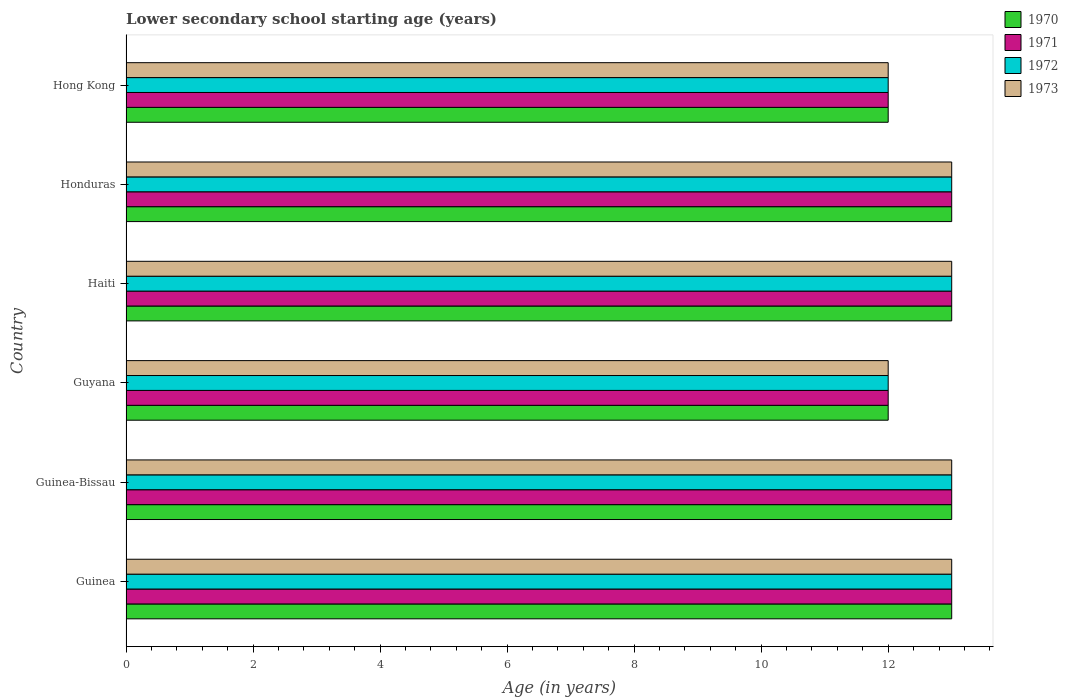How many different coloured bars are there?
Provide a short and direct response. 4. How many groups of bars are there?
Your response must be concise. 6. Are the number of bars per tick equal to the number of legend labels?
Keep it short and to the point. Yes. Are the number of bars on each tick of the Y-axis equal?
Give a very brief answer. Yes. How many bars are there on the 6th tick from the bottom?
Make the answer very short. 4. What is the label of the 2nd group of bars from the top?
Make the answer very short. Honduras. What is the lower secondary school starting age of children in 1970 in Guyana?
Offer a terse response. 12. Across all countries, what is the maximum lower secondary school starting age of children in 1973?
Give a very brief answer. 13. In which country was the lower secondary school starting age of children in 1972 maximum?
Offer a very short reply. Guinea. In which country was the lower secondary school starting age of children in 1970 minimum?
Make the answer very short. Guyana. What is the total lower secondary school starting age of children in 1970 in the graph?
Ensure brevity in your answer.  76. What is the average lower secondary school starting age of children in 1973 per country?
Offer a terse response. 12.67. What is the ratio of the lower secondary school starting age of children in 1973 in Guyana to that in Haiti?
Your answer should be compact. 0.92. Is the lower secondary school starting age of children in 1972 in Guyana less than that in Haiti?
Your response must be concise. Yes. What is the difference between the highest and the second highest lower secondary school starting age of children in 1972?
Give a very brief answer. 0. What is the difference between the highest and the lowest lower secondary school starting age of children in 1973?
Make the answer very short. 1. In how many countries, is the lower secondary school starting age of children in 1971 greater than the average lower secondary school starting age of children in 1971 taken over all countries?
Provide a succinct answer. 4. Is the sum of the lower secondary school starting age of children in 1973 in Guinea-Bissau and Guyana greater than the maximum lower secondary school starting age of children in 1970 across all countries?
Keep it short and to the point. Yes. Is it the case that in every country, the sum of the lower secondary school starting age of children in 1973 and lower secondary school starting age of children in 1970 is greater than the sum of lower secondary school starting age of children in 1971 and lower secondary school starting age of children in 1972?
Keep it short and to the point. No. What does the 2nd bar from the bottom in Guinea-Bissau represents?
Provide a short and direct response. 1971. Is it the case that in every country, the sum of the lower secondary school starting age of children in 1971 and lower secondary school starting age of children in 1970 is greater than the lower secondary school starting age of children in 1972?
Provide a succinct answer. Yes. How many bars are there?
Offer a very short reply. 24. Are all the bars in the graph horizontal?
Ensure brevity in your answer.  Yes. What is the difference between two consecutive major ticks on the X-axis?
Keep it short and to the point. 2. Does the graph contain any zero values?
Ensure brevity in your answer.  No. Where does the legend appear in the graph?
Your answer should be very brief. Top right. What is the title of the graph?
Provide a succinct answer. Lower secondary school starting age (years). What is the label or title of the X-axis?
Provide a short and direct response. Age (in years). What is the Age (in years) in 1970 in Guinea?
Make the answer very short. 13. What is the Age (in years) in 1972 in Guinea?
Ensure brevity in your answer.  13. What is the Age (in years) in 1973 in Guinea?
Ensure brevity in your answer.  13. What is the Age (in years) in 1970 in Guinea-Bissau?
Provide a succinct answer. 13. What is the Age (in years) of 1972 in Guinea-Bissau?
Keep it short and to the point. 13. What is the Age (in years) of 1973 in Guinea-Bissau?
Offer a terse response. 13. What is the Age (in years) of 1970 in Guyana?
Offer a very short reply. 12. What is the Age (in years) in 1971 in Guyana?
Provide a short and direct response. 12. What is the Age (in years) of 1972 in Guyana?
Offer a terse response. 12. What is the Age (in years) in 1973 in Haiti?
Keep it short and to the point. 13. What is the Age (in years) in 1970 in Honduras?
Give a very brief answer. 13. What is the Age (in years) in 1970 in Hong Kong?
Make the answer very short. 12. What is the Age (in years) of 1971 in Hong Kong?
Offer a terse response. 12. What is the Age (in years) of 1973 in Hong Kong?
Your response must be concise. 12. Across all countries, what is the maximum Age (in years) in 1970?
Provide a succinct answer. 13. Across all countries, what is the maximum Age (in years) in 1972?
Give a very brief answer. 13. Across all countries, what is the minimum Age (in years) of 1971?
Your answer should be compact. 12. Across all countries, what is the minimum Age (in years) of 1973?
Provide a short and direct response. 12. What is the total Age (in years) in 1970 in the graph?
Ensure brevity in your answer.  76. What is the total Age (in years) of 1971 in the graph?
Keep it short and to the point. 76. What is the difference between the Age (in years) of 1970 in Guinea and that in Guinea-Bissau?
Give a very brief answer. 0. What is the difference between the Age (in years) in 1973 in Guinea and that in Guinea-Bissau?
Provide a succinct answer. 0. What is the difference between the Age (in years) of 1973 in Guinea and that in Guyana?
Keep it short and to the point. 1. What is the difference between the Age (in years) of 1972 in Guinea and that in Haiti?
Ensure brevity in your answer.  0. What is the difference between the Age (in years) of 1970 in Guinea and that in Honduras?
Offer a very short reply. 0. What is the difference between the Age (in years) of 1972 in Guinea and that in Honduras?
Your answer should be very brief. 0. What is the difference between the Age (in years) in 1973 in Guinea and that in Honduras?
Your response must be concise. 0. What is the difference between the Age (in years) of 1970 in Guinea and that in Hong Kong?
Keep it short and to the point. 1. What is the difference between the Age (in years) of 1972 in Guinea and that in Hong Kong?
Offer a very short reply. 1. What is the difference between the Age (in years) of 1973 in Guinea and that in Hong Kong?
Give a very brief answer. 1. What is the difference between the Age (in years) in 1971 in Guinea-Bissau and that in Haiti?
Offer a very short reply. 0. What is the difference between the Age (in years) of 1972 in Guinea-Bissau and that in Haiti?
Give a very brief answer. 0. What is the difference between the Age (in years) of 1973 in Guinea-Bissau and that in Haiti?
Ensure brevity in your answer.  0. What is the difference between the Age (in years) of 1971 in Guinea-Bissau and that in Honduras?
Keep it short and to the point. 0. What is the difference between the Age (in years) in 1970 in Guinea-Bissau and that in Hong Kong?
Offer a very short reply. 1. What is the difference between the Age (in years) of 1973 in Guinea-Bissau and that in Hong Kong?
Ensure brevity in your answer.  1. What is the difference between the Age (in years) in 1970 in Guyana and that in Haiti?
Provide a succinct answer. -1. What is the difference between the Age (in years) in 1971 in Guyana and that in Honduras?
Your response must be concise. -1. What is the difference between the Age (in years) of 1973 in Guyana and that in Honduras?
Your answer should be very brief. -1. What is the difference between the Age (in years) in 1971 in Guyana and that in Hong Kong?
Keep it short and to the point. 0. What is the difference between the Age (in years) of 1970 in Haiti and that in Honduras?
Ensure brevity in your answer.  0. What is the difference between the Age (in years) of 1972 in Haiti and that in Honduras?
Offer a very short reply. 0. What is the difference between the Age (in years) in 1972 in Haiti and that in Hong Kong?
Provide a short and direct response. 1. What is the difference between the Age (in years) of 1973 in Haiti and that in Hong Kong?
Offer a terse response. 1. What is the difference between the Age (in years) of 1971 in Honduras and that in Hong Kong?
Provide a succinct answer. 1. What is the difference between the Age (in years) of 1970 in Guinea and the Age (in years) of 1971 in Guinea-Bissau?
Your answer should be compact. 0. What is the difference between the Age (in years) in 1970 in Guinea and the Age (in years) in 1972 in Guinea-Bissau?
Your answer should be compact. 0. What is the difference between the Age (in years) in 1971 in Guinea and the Age (in years) in 1973 in Guinea-Bissau?
Keep it short and to the point. 0. What is the difference between the Age (in years) in 1972 in Guinea and the Age (in years) in 1973 in Guinea-Bissau?
Provide a succinct answer. 0. What is the difference between the Age (in years) in 1970 in Guinea and the Age (in years) in 1972 in Guyana?
Provide a succinct answer. 1. What is the difference between the Age (in years) of 1971 in Guinea and the Age (in years) of 1973 in Guyana?
Your response must be concise. 1. What is the difference between the Age (in years) in 1972 in Guinea and the Age (in years) in 1973 in Guyana?
Your answer should be very brief. 1. What is the difference between the Age (in years) in 1970 in Guinea and the Age (in years) in 1973 in Haiti?
Give a very brief answer. 0. What is the difference between the Age (in years) of 1971 in Guinea and the Age (in years) of 1973 in Haiti?
Give a very brief answer. 0. What is the difference between the Age (in years) of 1970 in Guinea and the Age (in years) of 1972 in Honduras?
Keep it short and to the point. 0. What is the difference between the Age (in years) in 1971 in Guinea and the Age (in years) in 1973 in Honduras?
Your answer should be compact. 0. What is the difference between the Age (in years) in 1970 in Guinea and the Age (in years) in 1971 in Hong Kong?
Your response must be concise. 1. What is the difference between the Age (in years) of 1970 in Guinea and the Age (in years) of 1972 in Hong Kong?
Your answer should be compact. 1. What is the difference between the Age (in years) in 1971 in Guinea and the Age (in years) in 1972 in Hong Kong?
Offer a terse response. 1. What is the difference between the Age (in years) of 1971 in Guinea and the Age (in years) of 1973 in Hong Kong?
Your response must be concise. 1. What is the difference between the Age (in years) of 1972 in Guinea and the Age (in years) of 1973 in Hong Kong?
Keep it short and to the point. 1. What is the difference between the Age (in years) in 1970 in Guinea-Bissau and the Age (in years) in 1971 in Guyana?
Give a very brief answer. 1. What is the difference between the Age (in years) in 1970 in Guinea-Bissau and the Age (in years) in 1973 in Guyana?
Provide a succinct answer. 1. What is the difference between the Age (in years) in 1971 in Guinea-Bissau and the Age (in years) in 1973 in Guyana?
Keep it short and to the point. 1. What is the difference between the Age (in years) of 1972 in Guinea-Bissau and the Age (in years) of 1973 in Guyana?
Offer a terse response. 1. What is the difference between the Age (in years) of 1970 in Guinea-Bissau and the Age (in years) of 1972 in Haiti?
Your response must be concise. 0. What is the difference between the Age (in years) of 1970 in Guinea-Bissau and the Age (in years) of 1973 in Haiti?
Keep it short and to the point. 0. What is the difference between the Age (in years) of 1972 in Guinea-Bissau and the Age (in years) of 1973 in Haiti?
Provide a succinct answer. 0. What is the difference between the Age (in years) of 1970 in Guinea-Bissau and the Age (in years) of 1971 in Honduras?
Offer a terse response. 0. What is the difference between the Age (in years) of 1970 in Guinea-Bissau and the Age (in years) of 1972 in Honduras?
Keep it short and to the point. 0. What is the difference between the Age (in years) of 1970 in Guinea-Bissau and the Age (in years) of 1973 in Honduras?
Offer a very short reply. 0. What is the difference between the Age (in years) in 1971 in Guinea-Bissau and the Age (in years) in 1972 in Honduras?
Your answer should be compact. 0. What is the difference between the Age (in years) in 1971 in Guinea-Bissau and the Age (in years) in 1973 in Honduras?
Provide a short and direct response. 0. What is the difference between the Age (in years) of 1970 in Guinea-Bissau and the Age (in years) of 1971 in Hong Kong?
Your answer should be very brief. 1. What is the difference between the Age (in years) in 1970 in Guinea-Bissau and the Age (in years) in 1972 in Hong Kong?
Give a very brief answer. 1. What is the difference between the Age (in years) in 1971 in Guinea-Bissau and the Age (in years) in 1972 in Hong Kong?
Provide a short and direct response. 1. What is the difference between the Age (in years) in 1972 in Guinea-Bissau and the Age (in years) in 1973 in Hong Kong?
Ensure brevity in your answer.  1. What is the difference between the Age (in years) of 1970 in Guyana and the Age (in years) of 1971 in Haiti?
Your response must be concise. -1. What is the difference between the Age (in years) of 1971 in Guyana and the Age (in years) of 1972 in Haiti?
Ensure brevity in your answer.  -1. What is the difference between the Age (in years) of 1971 in Guyana and the Age (in years) of 1973 in Haiti?
Your response must be concise. -1. What is the difference between the Age (in years) of 1972 in Guyana and the Age (in years) of 1973 in Haiti?
Keep it short and to the point. -1. What is the difference between the Age (in years) in 1970 in Guyana and the Age (in years) in 1971 in Honduras?
Keep it short and to the point. -1. What is the difference between the Age (in years) in 1970 in Guyana and the Age (in years) in 1973 in Honduras?
Your response must be concise. -1. What is the difference between the Age (in years) in 1972 in Guyana and the Age (in years) in 1973 in Honduras?
Your answer should be very brief. -1. What is the difference between the Age (in years) of 1970 in Guyana and the Age (in years) of 1971 in Hong Kong?
Offer a terse response. 0. What is the difference between the Age (in years) of 1971 in Guyana and the Age (in years) of 1972 in Hong Kong?
Give a very brief answer. 0. What is the difference between the Age (in years) in 1972 in Guyana and the Age (in years) in 1973 in Hong Kong?
Give a very brief answer. 0. What is the difference between the Age (in years) of 1970 in Haiti and the Age (in years) of 1972 in Honduras?
Make the answer very short. 0. What is the difference between the Age (in years) in 1970 in Haiti and the Age (in years) in 1973 in Honduras?
Give a very brief answer. 0. What is the difference between the Age (in years) of 1972 in Haiti and the Age (in years) of 1973 in Honduras?
Offer a terse response. 0. What is the difference between the Age (in years) of 1970 in Haiti and the Age (in years) of 1971 in Hong Kong?
Your response must be concise. 1. What is the difference between the Age (in years) in 1970 in Haiti and the Age (in years) in 1972 in Hong Kong?
Give a very brief answer. 1. What is the difference between the Age (in years) of 1970 in Haiti and the Age (in years) of 1973 in Hong Kong?
Offer a very short reply. 1. What is the difference between the Age (in years) in 1971 in Haiti and the Age (in years) in 1972 in Hong Kong?
Ensure brevity in your answer.  1. What is the difference between the Age (in years) in 1970 in Honduras and the Age (in years) in 1972 in Hong Kong?
Offer a terse response. 1. What is the average Age (in years) in 1970 per country?
Your answer should be very brief. 12.67. What is the average Age (in years) in 1971 per country?
Provide a succinct answer. 12.67. What is the average Age (in years) in 1972 per country?
Your answer should be very brief. 12.67. What is the average Age (in years) of 1973 per country?
Provide a short and direct response. 12.67. What is the difference between the Age (in years) of 1970 and Age (in years) of 1973 in Guinea?
Provide a succinct answer. 0. What is the difference between the Age (in years) in 1971 and Age (in years) in 1973 in Guinea?
Make the answer very short. 0. What is the difference between the Age (in years) of 1972 and Age (in years) of 1973 in Guinea?
Keep it short and to the point. 0. What is the difference between the Age (in years) in 1970 and Age (in years) in 1972 in Guinea-Bissau?
Keep it short and to the point. 0. What is the difference between the Age (in years) of 1970 and Age (in years) of 1973 in Guinea-Bissau?
Make the answer very short. 0. What is the difference between the Age (in years) in 1971 and Age (in years) in 1973 in Guinea-Bissau?
Provide a succinct answer. 0. What is the difference between the Age (in years) in 1970 and Age (in years) in 1971 in Guyana?
Your answer should be very brief. 0. What is the difference between the Age (in years) of 1970 and Age (in years) of 1972 in Guyana?
Your answer should be very brief. 0. What is the difference between the Age (in years) in 1972 and Age (in years) in 1973 in Guyana?
Your answer should be compact. 0. What is the difference between the Age (in years) of 1970 and Age (in years) of 1971 in Haiti?
Your response must be concise. 0. What is the difference between the Age (in years) in 1970 and Age (in years) in 1972 in Haiti?
Give a very brief answer. 0. What is the difference between the Age (in years) in 1971 and Age (in years) in 1972 in Haiti?
Offer a very short reply. 0. What is the difference between the Age (in years) of 1972 and Age (in years) of 1973 in Haiti?
Provide a short and direct response. 0. What is the difference between the Age (in years) in 1970 and Age (in years) in 1971 in Honduras?
Give a very brief answer. 0. What is the difference between the Age (in years) of 1971 and Age (in years) of 1972 in Honduras?
Provide a short and direct response. 0. What is the difference between the Age (in years) of 1972 and Age (in years) of 1973 in Honduras?
Offer a very short reply. 0. What is the difference between the Age (in years) of 1970 and Age (in years) of 1972 in Hong Kong?
Give a very brief answer. 0. What is the difference between the Age (in years) of 1971 and Age (in years) of 1973 in Hong Kong?
Your answer should be compact. 0. What is the ratio of the Age (in years) in 1971 in Guinea to that in Guinea-Bissau?
Make the answer very short. 1. What is the ratio of the Age (in years) in 1972 in Guinea to that in Guinea-Bissau?
Provide a short and direct response. 1. What is the ratio of the Age (in years) in 1973 in Guinea to that in Guinea-Bissau?
Give a very brief answer. 1. What is the ratio of the Age (in years) in 1971 in Guinea to that in Guyana?
Your answer should be very brief. 1.08. What is the ratio of the Age (in years) of 1973 in Guinea to that in Guyana?
Offer a terse response. 1.08. What is the ratio of the Age (in years) in 1970 in Guinea to that in Haiti?
Ensure brevity in your answer.  1. What is the ratio of the Age (in years) in 1973 in Guinea to that in Haiti?
Give a very brief answer. 1. What is the ratio of the Age (in years) in 1970 in Guinea to that in Honduras?
Provide a succinct answer. 1. What is the ratio of the Age (in years) of 1972 in Guinea to that in Hong Kong?
Your response must be concise. 1.08. What is the ratio of the Age (in years) of 1970 in Guinea-Bissau to that in Guyana?
Provide a short and direct response. 1.08. What is the ratio of the Age (in years) of 1972 in Guinea-Bissau to that in Guyana?
Provide a succinct answer. 1.08. What is the ratio of the Age (in years) of 1973 in Guinea-Bissau to that in Guyana?
Ensure brevity in your answer.  1.08. What is the ratio of the Age (in years) of 1970 in Guinea-Bissau to that in Haiti?
Offer a terse response. 1. What is the ratio of the Age (in years) of 1972 in Guinea-Bissau to that in Haiti?
Your response must be concise. 1. What is the ratio of the Age (in years) of 1973 in Guinea-Bissau to that in Haiti?
Your answer should be very brief. 1. What is the ratio of the Age (in years) of 1970 in Guinea-Bissau to that in Honduras?
Your answer should be very brief. 1. What is the ratio of the Age (in years) of 1971 in Guinea-Bissau to that in Hong Kong?
Keep it short and to the point. 1.08. What is the ratio of the Age (in years) in 1972 in Guinea-Bissau to that in Hong Kong?
Make the answer very short. 1.08. What is the ratio of the Age (in years) of 1971 in Guyana to that in Haiti?
Make the answer very short. 0.92. What is the ratio of the Age (in years) in 1972 in Guyana to that in Haiti?
Offer a very short reply. 0.92. What is the ratio of the Age (in years) of 1973 in Guyana to that in Haiti?
Your response must be concise. 0.92. What is the ratio of the Age (in years) in 1970 in Guyana to that in Honduras?
Provide a short and direct response. 0.92. What is the ratio of the Age (in years) in 1971 in Guyana to that in Honduras?
Your answer should be very brief. 0.92. What is the ratio of the Age (in years) of 1970 in Guyana to that in Hong Kong?
Provide a succinct answer. 1. What is the difference between the highest and the second highest Age (in years) of 1970?
Your answer should be very brief. 0. What is the difference between the highest and the second highest Age (in years) of 1971?
Make the answer very short. 0. What is the difference between the highest and the second highest Age (in years) of 1972?
Your response must be concise. 0. What is the difference between the highest and the lowest Age (in years) of 1971?
Your response must be concise. 1. What is the difference between the highest and the lowest Age (in years) of 1972?
Provide a succinct answer. 1. What is the difference between the highest and the lowest Age (in years) in 1973?
Give a very brief answer. 1. 